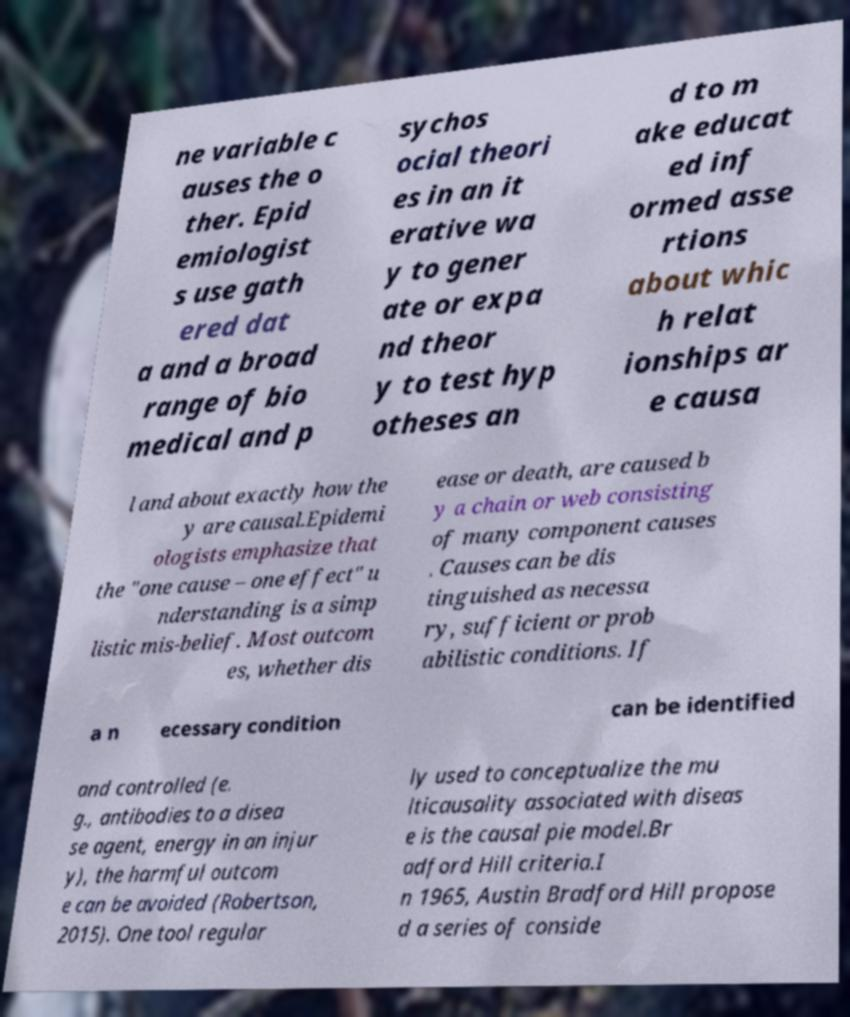What messages or text are displayed in this image? I need them in a readable, typed format. ne variable c auses the o ther. Epid emiologist s use gath ered dat a and a broad range of bio medical and p sychos ocial theori es in an it erative wa y to gener ate or expa nd theor y to test hyp otheses an d to m ake educat ed inf ormed asse rtions about whic h relat ionships ar e causa l and about exactly how the y are causal.Epidemi ologists emphasize that the "one cause – one effect" u nderstanding is a simp listic mis-belief. Most outcom es, whether dis ease or death, are caused b y a chain or web consisting of many component causes . Causes can be dis tinguished as necessa ry, sufficient or prob abilistic conditions. If a n ecessary condition can be identified and controlled (e. g., antibodies to a disea se agent, energy in an injur y), the harmful outcom e can be avoided (Robertson, 2015). One tool regular ly used to conceptualize the mu lticausality associated with diseas e is the causal pie model.Br adford Hill criteria.I n 1965, Austin Bradford Hill propose d a series of conside 